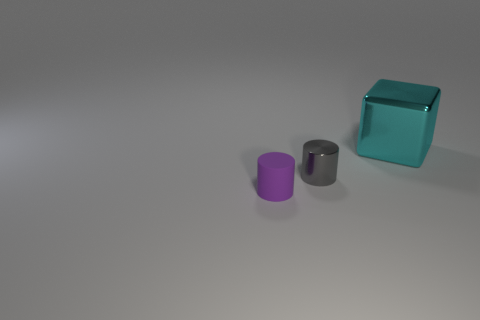Is there any other thing that is the same material as the purple thing?
Offer a very short reply. No. There is a small purple object; is its shape the same as the metallic thing that is right of the tiny metal thing?
Ensure brevity in your answer.  No. How many objects are on the left side of the large cyan block and on the right side of the small purple cylinder?
Your response must be concise. 1. Are the large cyan thing and the cylinder on the left side of the small metal object made of the same material?
Offer a terse response. No. Are there the same number of cyan things that are in front of the matte cylinder and tiny cyan rubber cylinders?
Offer a terse response. Yes. The object on the left side of the small gray shiny cylinder is what color?
Make the answer very short. Purple. How many other objects are the same color as the big block?
Your response must be concise. 0. Is there any other thing that is the same size as the block?
Keep it short and to the point. No. There is a object in front of the metallic cylinder; is it the same size as the large cyan metallic block?
Offer a very short reply. No. What is the thing left of the gray shiny cylinder made of?
Provide a succinct answer. Rubber. 